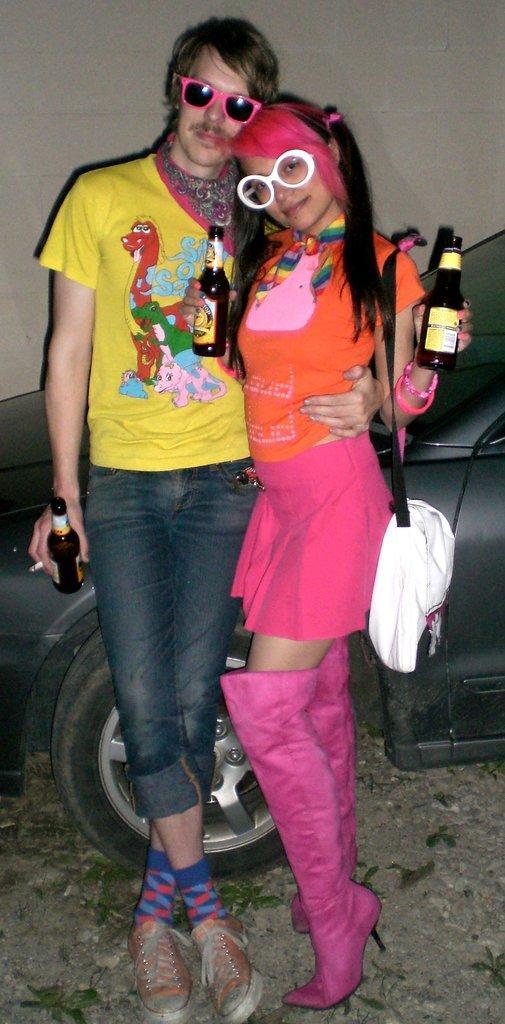Could you give a brief overview of what you see in this image? In this picture I can see there is a man and a woman standing here and they are holding beer bottles in their hands and in the backdrop I can see there a car parked here and there is a wall. 